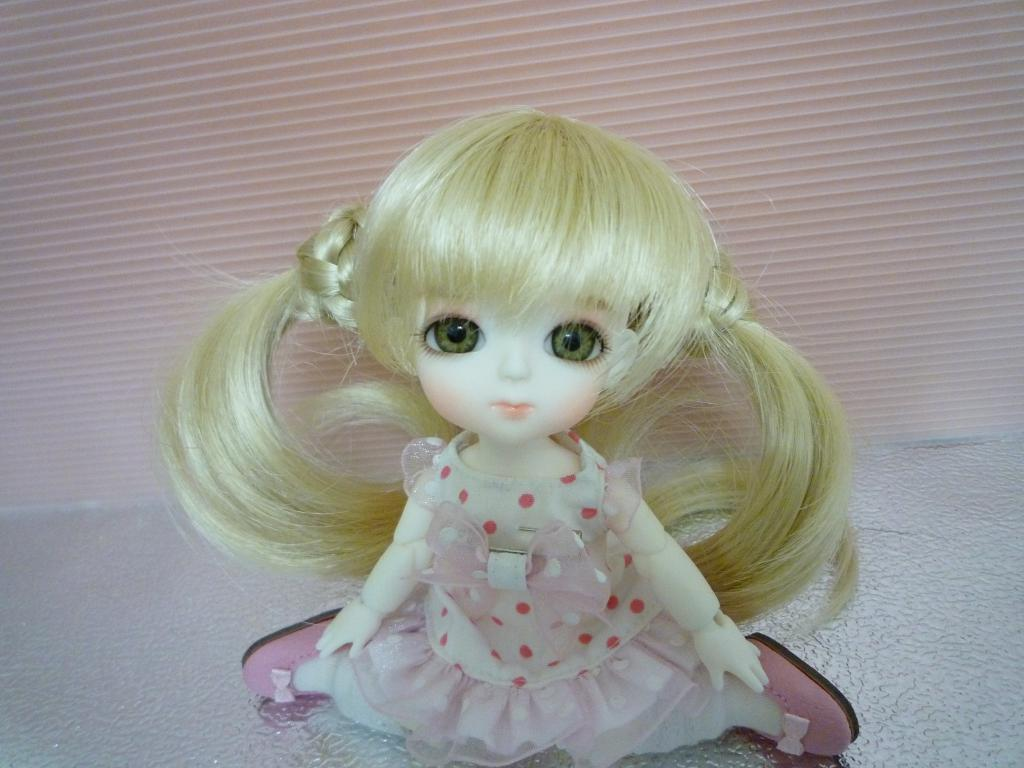What is the main subject of the image? There is a Barbie doll in the image. Can you describe the background of the image? There is a curtain in the background of the image. What type of music is the band playing in the background of the image? There is no band present in the image, so it is not possible to determine what type of music they might be playing. 